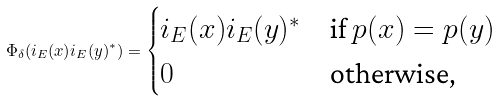Convert formula to latex. <formula><loc_0><loc_0><loc_500><loc_500>\Phi _ { \delta } ( i _ { E } ( x ) i _ { E } ( y ) ^ { * } ) = \begin{cases} i _ { E } ( x ) i _ { E } ( y ) ^ { * } & \text {if $p(x) = p(y)$} \\ 0 & \text {otherwise,} \end{cases}</formula> 